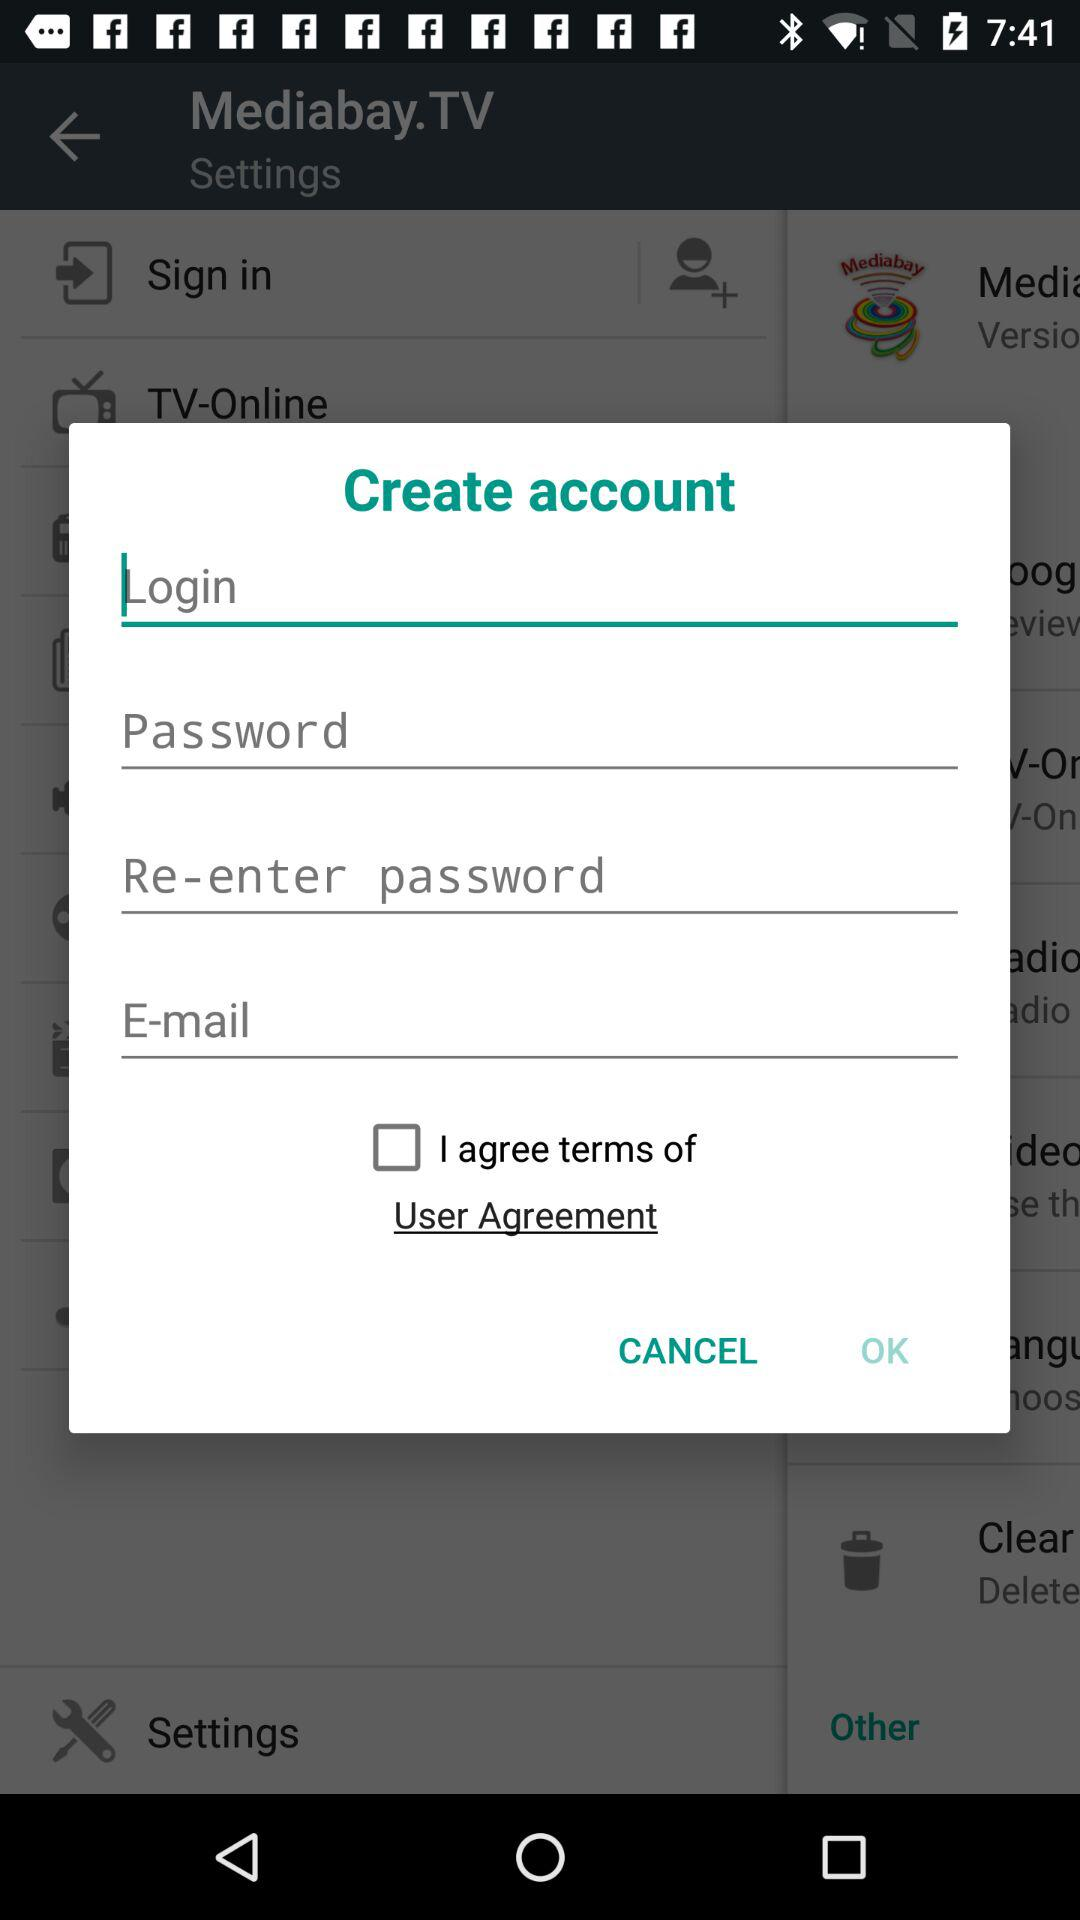How many text inputs are on this page?
Answer the question using a single word or phrase. 4 